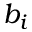<formula> <loc_0><loc_0><loc_500><loc_500>b _ { i }</formula> 